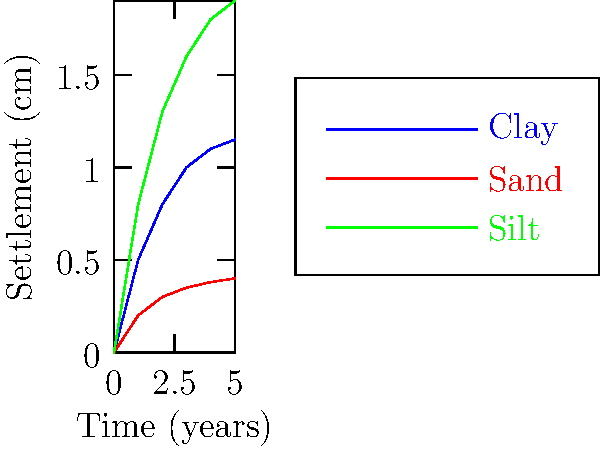As a risk manager assessing the long-term stability of a building investment, you're presented with the above graph showing foundation settlement over time for different soil types. Which soil type exhibits the least total settlement after 5 years and would likely be the most stable for long-term investment? To determine the soil type with the least total settlement after 5 years, we need to analyze the graph for each soil type:

1. Clay (blue line):
   - Initial settlement is rapid
   - Settles to approximately 1.15 cm at 5 years
   - Shows a gradual increase in settlement over time

2. Sand (red line):
   - Initial settlement is less rapid than clay
   - Settles to approximately 0.4 cm at 5 years
   - Shows the least overall settlement among the three soil types

3. Silt (green line):
   - Initial settlement is the most rapid
   - Settles to approximately 1.9 cm at 5 years
   - Shows the highest overall settlement among the three soil types

Comparing the final settlement values at 5 years:
- Clay: ~1.15 cm
- Sand: ~0.4 cm
- Silt: ~1.9 cm

Sand exhibits the least total settlement after 5 years, reaching only about 0.4 cm. This indicates that sand would likely be the most stable soil type for long-term investment, as it shows the least amount of movement over time.

From a risk management perspective, choosing a foundation on sandy soil would minimize the risk of structural issues due to differential settlement, potentially reducing long-term maintenance costs and preserving the building's value.
Answer: Sand 